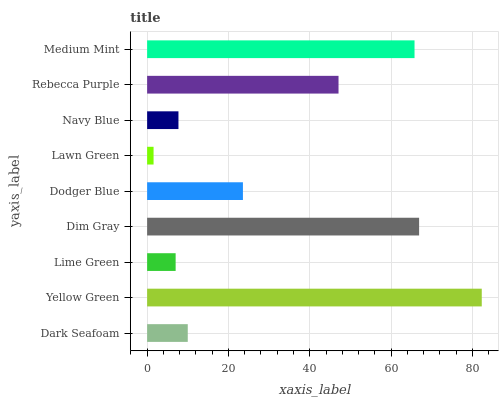Is Lawn Green the minimum?
Answer yes or no. Yes. Is Yellow Green the maximum?
Answer yes or no. Yes. Is Lime Green the minimum?
Answer yes or no. No. Is Lime Green the maximum?
Answer yes or no. No. Is Yellow Green greater than Lime Green?
Answer yes or no. Yes. Is Lime Green less than Yellow Green?
Answer yes or no. Yes. Is Lime Green greater than Yellow Green?
Answer yes or no. No. Is Yellow Green less than Lime Green?
Answer yes or no. No. Is Dodger Blue the high median?
Answer yes or no. Yes. Is Dodger Blue the low median?
Answer yes or no. Yes. Is Medium Mint the high median?
Answer yes or no. No. Is Lawn Green the low median?
Answer yes or no. No. 